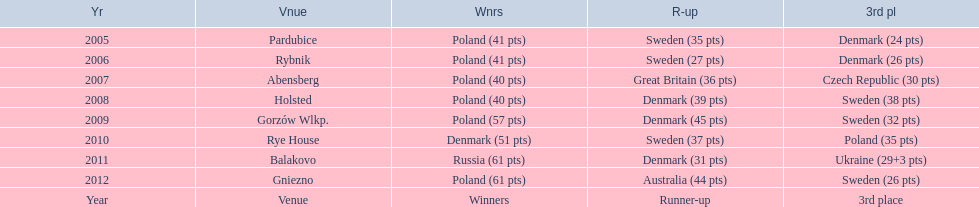Did holland win the 2010 championship? if not who did? Rye House. What did position did holland they rank? 3rd place. 